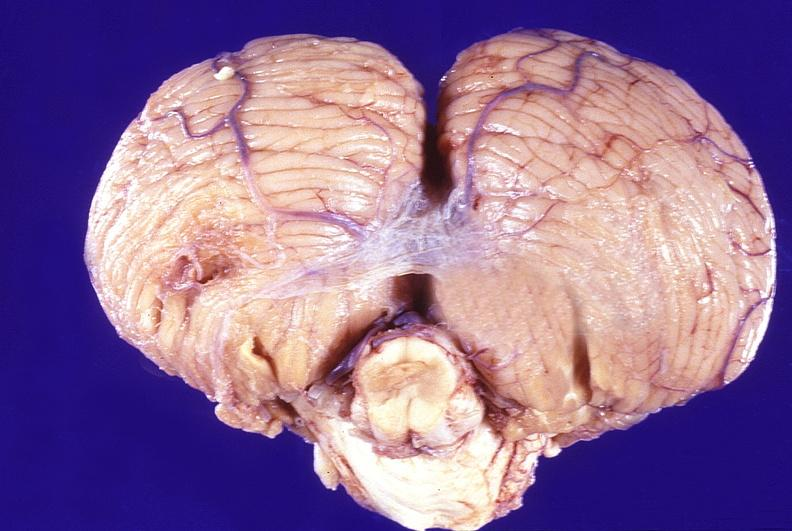what is present?
Answer the question using a single word or phrase. Nervous 